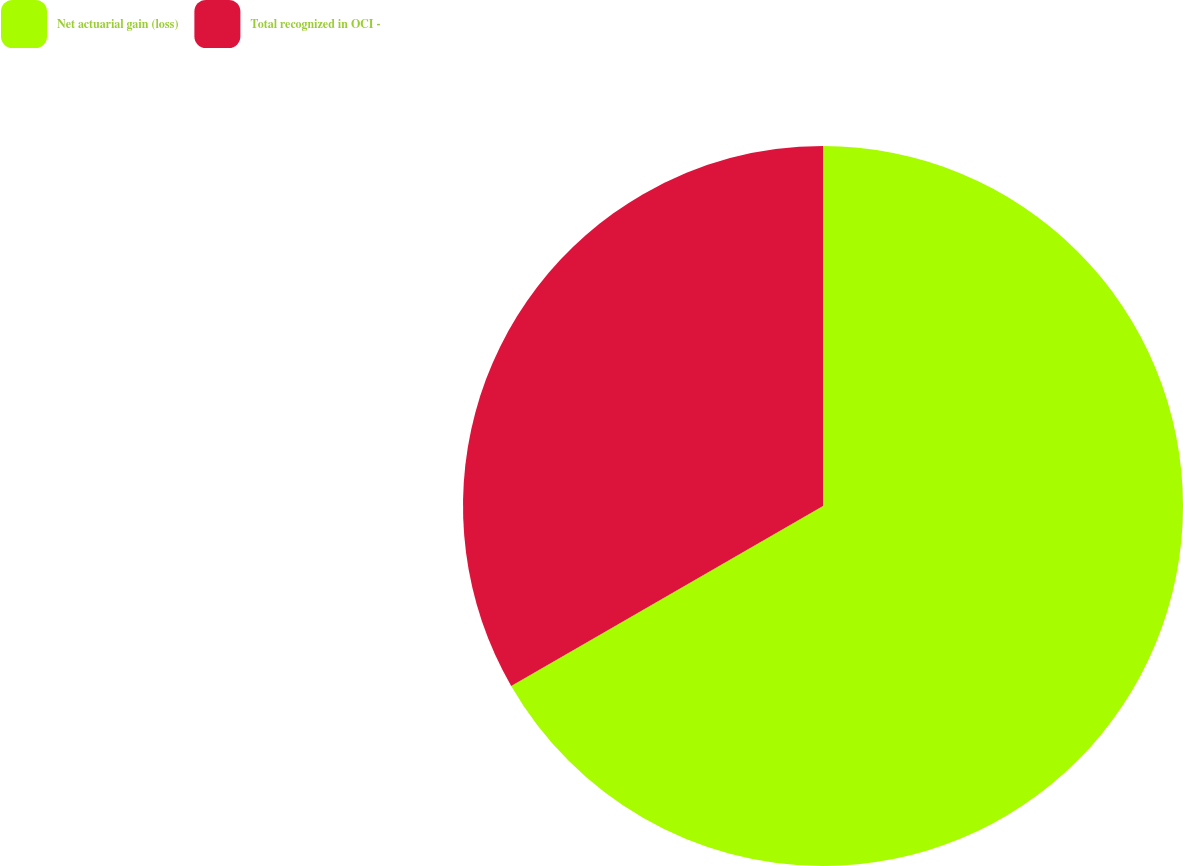Convert chart. <chart><loc_0><loc_0><loc_500><loc_500><pie_chart><fcel>Net actuarial gain (loss)<fcel>Total recognized in OCI -<nl><fcel>66.67%<fcel>33.33%<nl></chart> 